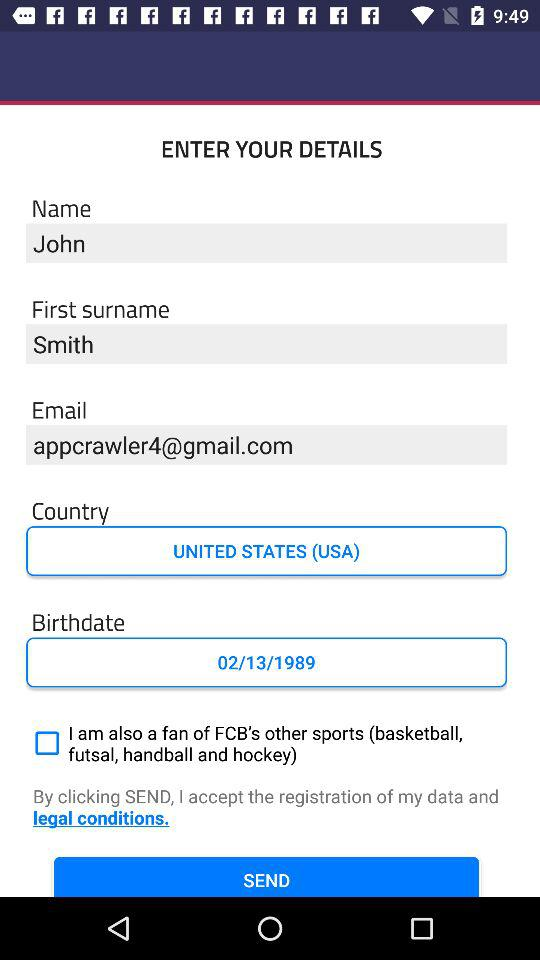What is the country name? The country name is the United States (USA). 